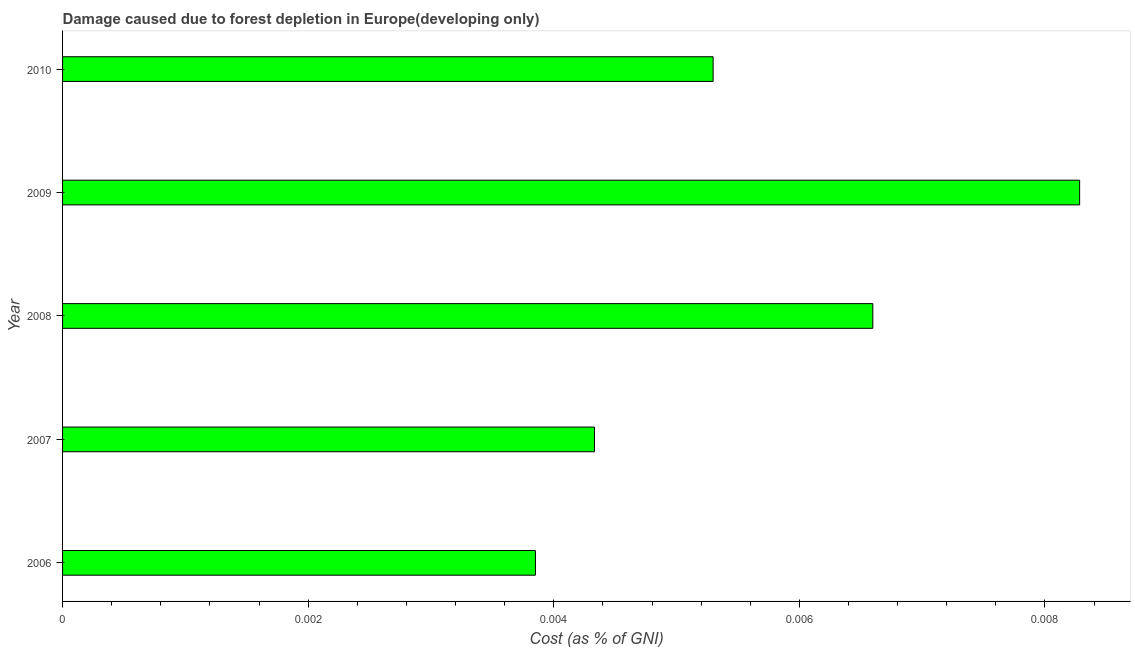Does the graph contain any zero values?
Give a very brief answer. No. Does the graph contain grids?
Keep it short and to the point. No. What is the title of the graph?
Your answer should be very brief. Damage caused due to forest depletion in Europe(developing only). What is the label or title of the X-axis?
Provide a succinct answer. Cost (as % of GNI). What is the label or title of the Y-axis?
Keep it short and to the point. Year. What is the damage caused due to forest depletion in 2008?
Give a very brief answer. 0.01. Across all years, what is the maximum damage caused due to forest depletion?
Keep it short and to the point. 0.01. Across all years, what is the minimum damage caused due to forest depletion?
Ensure brevity in your answer.  0. In which year was the damage caused due to forest depletion maximum?
Make the answer very short. 2009. What is the sum of the damage caused due to forest depletion?
Offer a very short reply. 0.03. What is the difference between the damage caused due to forest depletion in 2006 and 2009?
Provide a short and direct response. -0. What is the average damage caused due to forest depletion per year?
Keep it short and to the point. 0.01. What is the median damage caused due to forest depletion?
Provide a succinct answer. 0.01. Do a majority of the years between 2009 and 2010 (inclusive) have damage caused due to forest depletion greater than 0.0004 %?
Your answer should be very brief. Yes. What is the ratio of the damage caused due to forest depletion in 2006 to that in 2008?
Your answer should be compact. 0.58. What is the difference between the highest and the second highest damage caused due to forest depletion?
Give a very brief answer. 0. What is the difference between the highest and the lowest damage caused due to forest depletion?
Offer a very short reply. 0. In how many years, is the damage caused due to forest depletion greater than the average damage caused due to forest depletion taken over all years?
Keep it short and to the point. 2. How many years are there in the graph?
Offer a very short reply. 5. What is the difference between two consecutive major ticks on the X-axis?
Offer a very short reply. 0. Are the values on the major ticks of X-axis written in scientific E-notation?
Your answer should be compact. No. What is the Cost (as % of GNI) of 2006?
Your answer should be compact. 0. What is the Cost (as % of GNI) in 2007?
Keep it short and to the point. 0. What is the Cost (as % of GNI) in 2008?
Your answer should be very brief. 0.01. What is the Cost (as % of GNI) in 2009?
Make the answer very short. 0.01. What is the Cost (as % of GNI) in 2010?
Your answer should be very brief. 0.01. What is the difference between the Cost (as % of GNI) in 2006 and 2007?
Keep it short and to the point. -0. What is the difference between the Cost (as % of GNI) in 2006 and 2008?
Make the answer very short. -0. What is the difference between the Cost (as % of GNI) in 2006 and 2009?
Make the answer very short. -0. What is the difference between the Cost (as % of GNI) in 2006 and 2010?
Your answer should be very brief. -0. What is the difference between the Cost (as % of GNI) in 2007 and 2008?
Offer a very short reply. -0. What is the difference between the Cost (as % of GNI) in 2007 and 2009?
Offer a terse response. -0. What is the difference between the Cost (as % of GNI) in 2007 and 2010?
Provide a succinct answer. -0. What is the difference between the Cost (as % of GNI) in 2008 and 2009?
Provide a succinct answer. -0. What is the difference between the Cost (as % of GNI) in 2008 and 2010?
Ensure brevity in your answer.  0. What is the difference between the Cost (as % of GNI) in 2009 and 2010?
Offer a very short reply. 0. What is the ratio of the Cost (as % of GNI) in 2006 to that in 2007?
Your response must be concise. 0.89. What is the ratio of the Cost (as % of GNI) in 2006 to that in 2008?
Provide a succinct answer. 0.58. What is the ratio of the Cost (as % of GNI) in 2006 to that in 2009?
Your answer should be compact. 0.47. What is the ratio of the Cost (as % of GNI) in 2006 to that in 2010?
Offer a very short reply. 0.73. What is the ratio of the Cost (as % of GNI) in 2007 to that in 2008?
Your answer should be very brief. 0.66. What is the ratio of the Cost (as % of GNI) in 2007 to that in 2009?
Ensure brevity in your answer.  0.52. What is the ratio of the Cost (as % of GNI) in 2007 to that in 2010?
Make the answer very short. 0.82. What is the ratio of the Cost (as % of GNI) in 2008 to that in 2009?
Ensure brevity in your answer.  0.8. What is the ratio of the Cost (as % of GNI) in 2008 to that in 2010?
Provide a short and direct response. 1.25. What is the ratio of the Cost (as % of GNI) in 2009 to that in 2010?
Offer a very short reply. 1.56. 